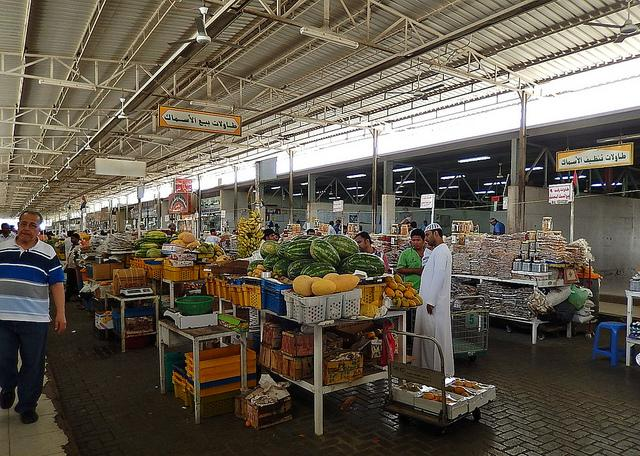What part of the market is located here? Please explain your reasoning. fruit stand. There are melons, bananas and other produce available for sale. 